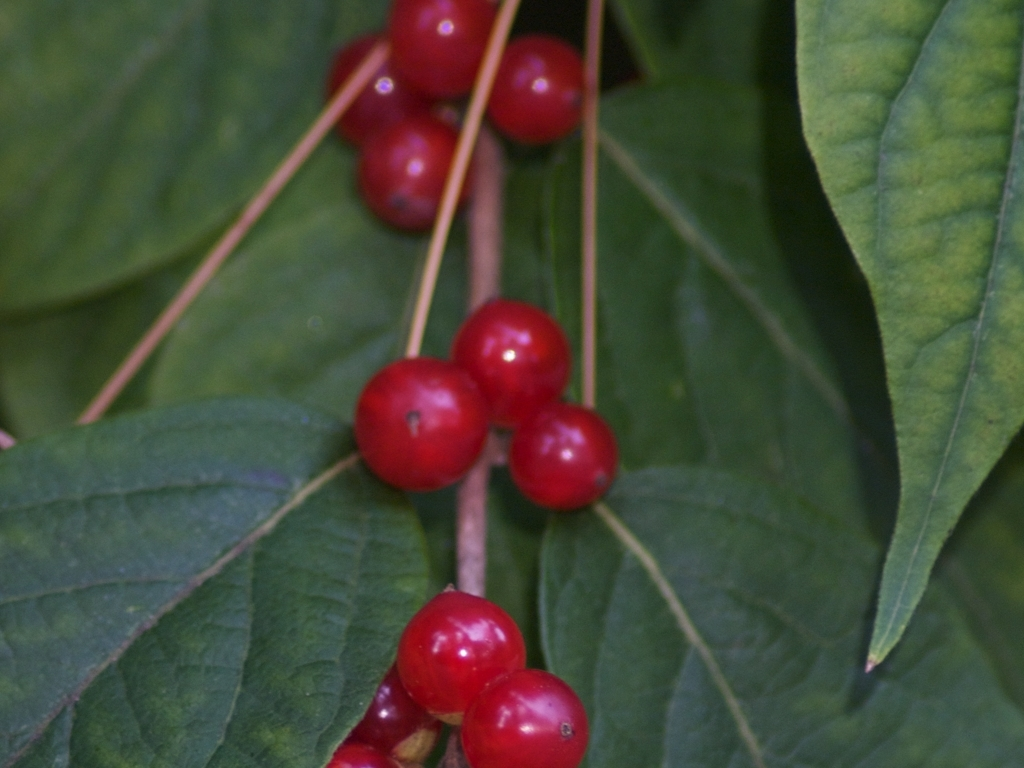What time of year do you think this photo was taken? According to the fullness and color of the berries, it appears that the photo was likely taken in late summer or early autumn. This is typically the season when many berry-producing plants reach full ripeness and display a vibrant hue, attracting birds and other wildlife for seed dispersal. 